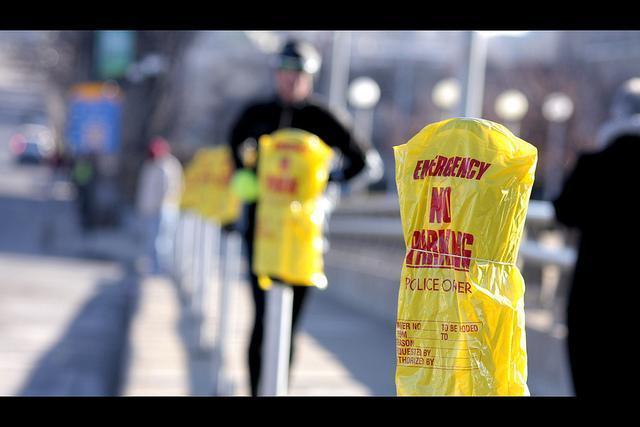What might be happening on this street?
From the following four choices, select the correct answer to address the question.
Options: Parade, fire, sale, rush hour. Parade. 